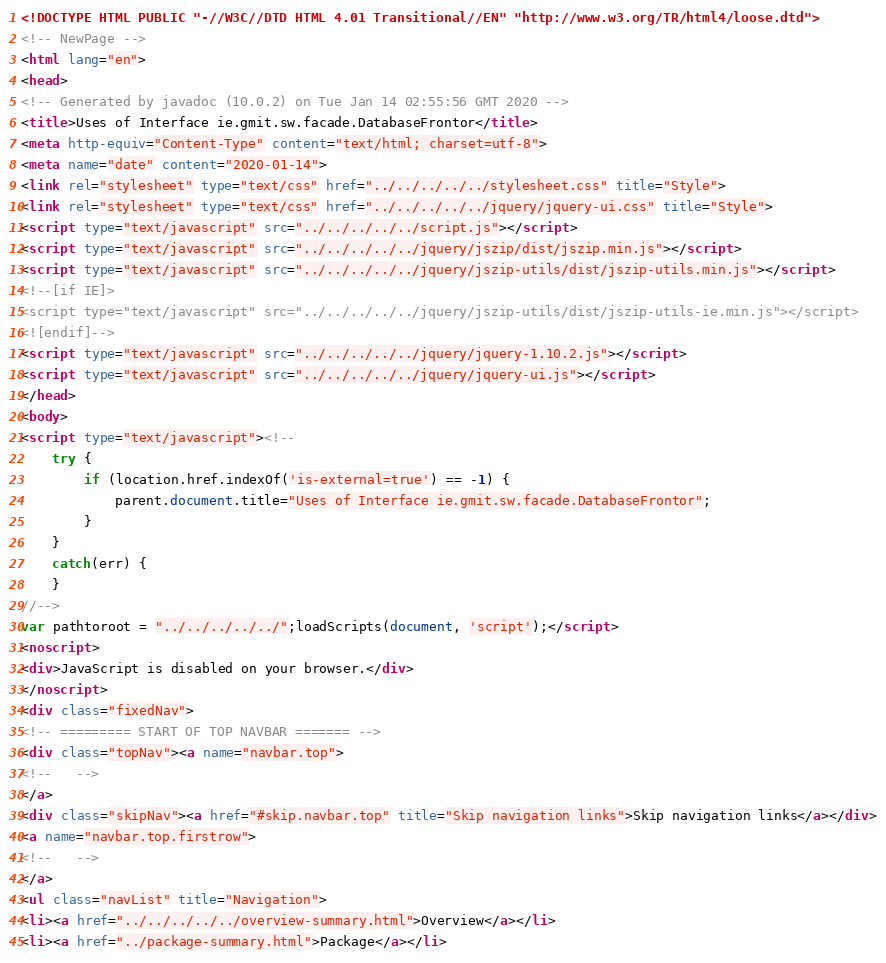Convert code to text. <code><loc_0><loc_0><loc_500><loc_500><_HTML_><!DOCTYPE HTML PUBLIC "-//W3C//DTD HTML 4.01 Transitional//EN" "http://www.w3.org/TR/html4/loose.dtd">
<!-- NewPage -->
<html lang="en">
<head>
<!-- Generated by javadoc (10.0.2) on Tue Jan 14 02:55:56 GMT 2020 -->
<title>Uses of Interface ie.gmit.sw.facade.DatabaseFrontor</title>
<meta http-equiv="Content-Type" content="text/html; charset=utf-8">
<meta name="date" content="2020-01-14">
<link rel="stylesheet" type="text/css" href="../../../../../stylesheet.css" title="Style">
<link rel="stylesheet" type="text/css" href="../../../../../jquery/jquery-ui.css" title="Style">
<script type="text/javascript" src="../../../../../script.js"></script>
<script type="text/javascript" src="../../../../../jquery/jszip/dist/jszip.min.js"></script>
<script type="text/javascript" src="../../../../../jquery/jszip-utils/dist/jszip-utils.min.js"></script>
<!--[if IE]>
<script type="text/javascript" src="../../../../../jquery/jszip-utils/dist/jszip-utils-ie.min.js"></script>
<![endif]-->
<script type="text/javascript" src="../../../../../jquery/jquery-1.10.2.js"></script>
<script type="text/javascript" src="../../../../../jquery/jquery-ui.js"></script>
</head>
<body>
<script type="text/javascript"><!--
    try {
        if (location.href.indexOf('is-external=true') == -1) {
            parent.document.title="Uses of Interface ie.gmit.sw.facade.DatabaseFrontor";
        }
    }
    catch(err) {
    }
//-->
var pathtoroot = "../../../../../";loadScripts(document, 'script');</script>
<noscript>
<div>JavaScript is disabled on your browser.</div>
</noscript>
<div class="fixedNav">
<!-- ========= START OF TOP NAVBAR ======= -->
<div class="topNav"><a name="navbar.top">
<!--   -->
</a>
<div class="skipNav"><a href="#skip.navbar.top" title="Skip navigation links">Skip navigation links</a></div>
<a name="navbar.top.firstrow">
<!--   -->
</a>
<ul class="navList" title="Navigation">
<li><a href="../../../../../overview-summary.html">Overview</a></li>
<li><a href="../package-summary.html">Package</a></li></code> 